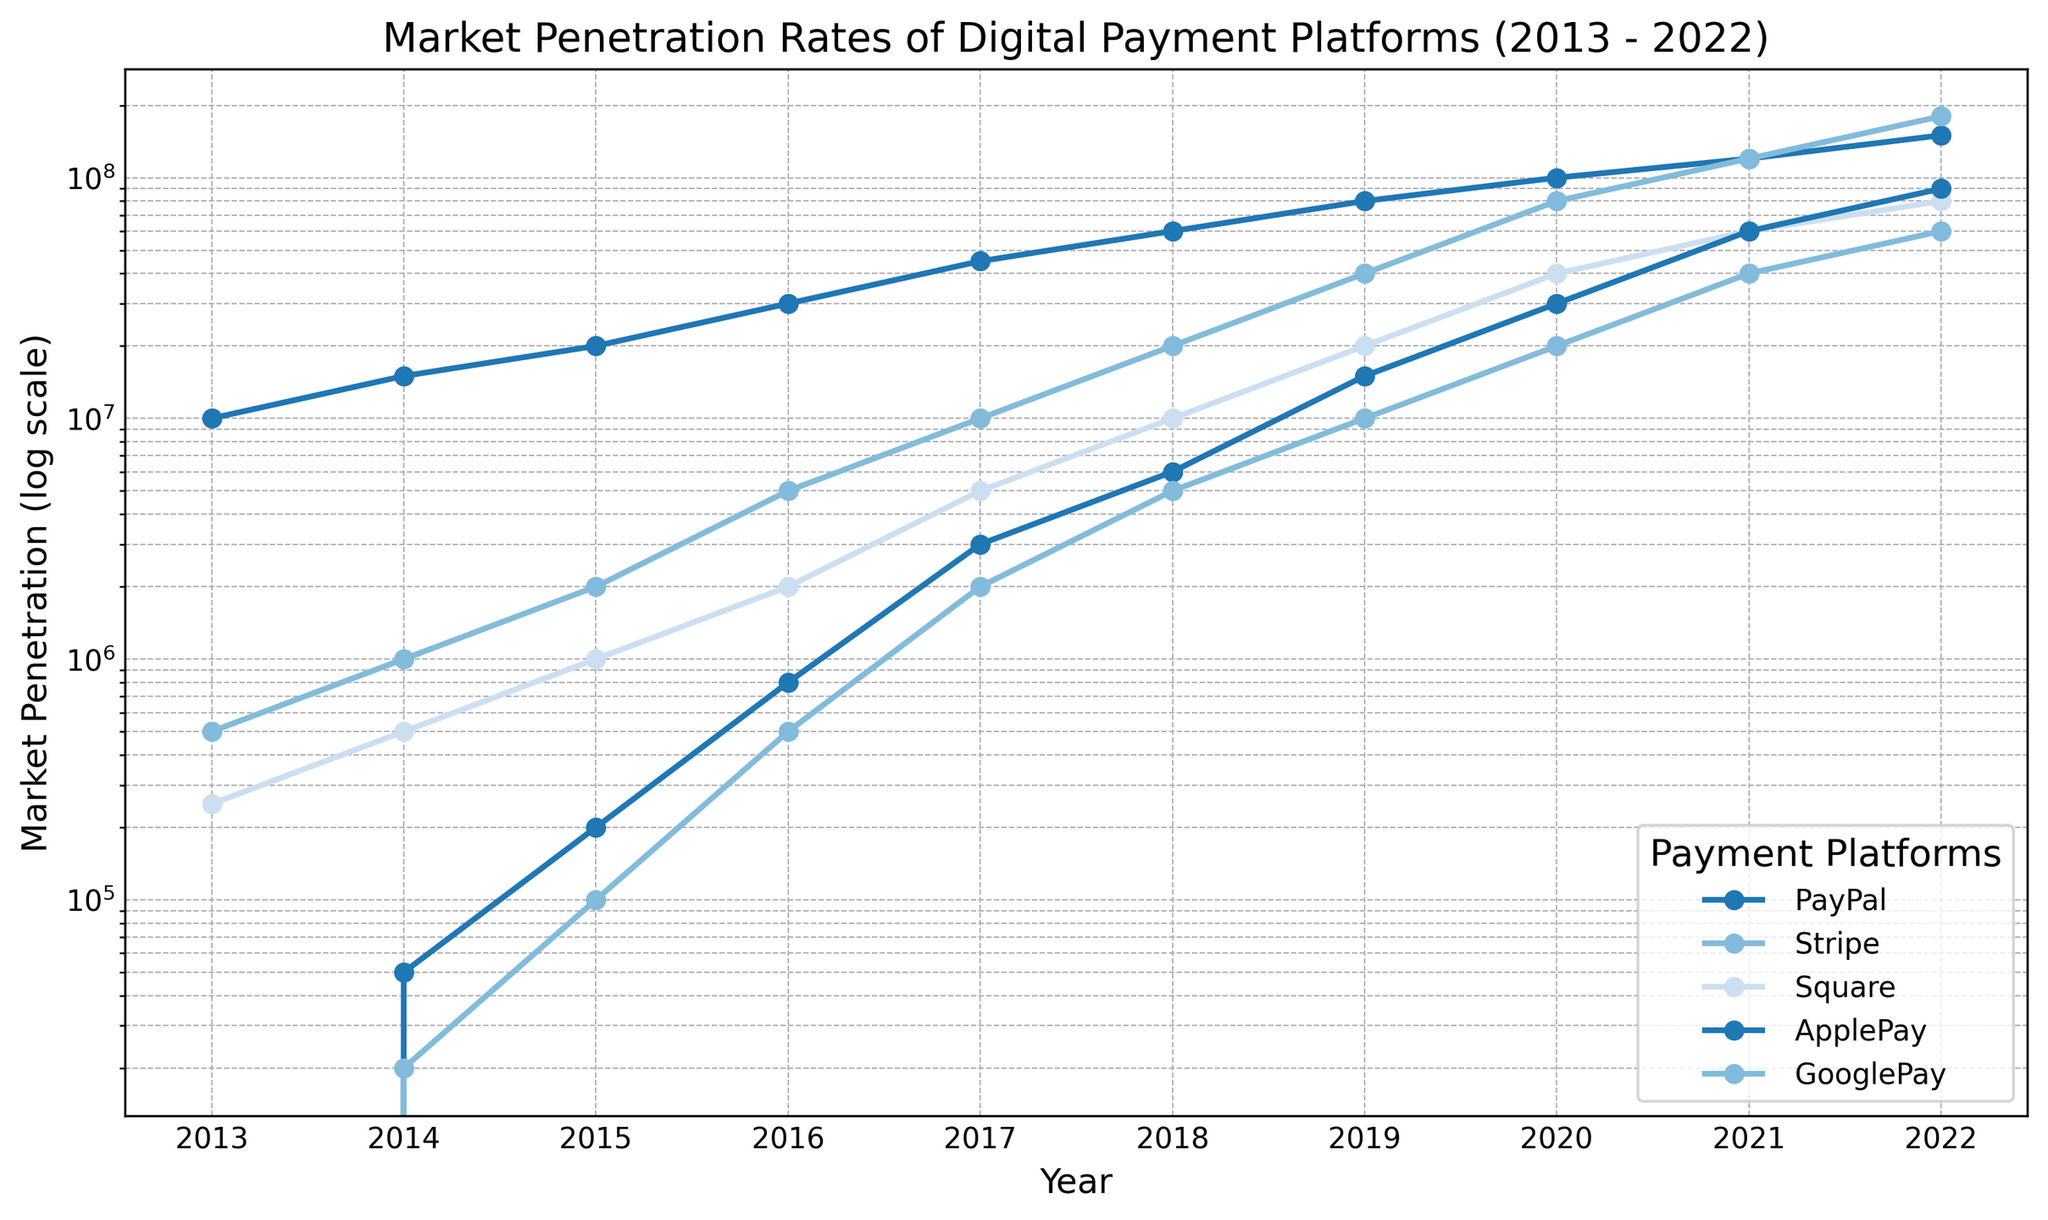What platform showed the largest growth in market penetration from 2013 to 2022? To determine the platform with the largest growth, calculate the difference between the market penetration in 2022 and 2013 for each platform. PayPal: 150,000,000 - 10,000,000 = 140,000,000; Stripe: 180,000,000 - 500,000 = 179,500,000; Square: 80,000,000 - 250,000 = 79,750,000; ApplePay: 90,000,000 - 0 = 90,000,000; GooglePay: 60,000,000 - 0 = 60,000,000. Stripe shows the largest growth of 179,500,000.
Answer: Stripe Which year did ApplePay surpass Square in market penetration? Observe the plotted lines for ApplePay and Square and identify the year where ApplePay's line crosses above Square's line. In 2021, ApplePay surpassed Square.
Answer: 2021 By how much did Google's market penetration increase between 2015 and 2020? Find Google's market penetration in 2015 and 2020. Then, subtract the former from the latter: 20,000,000 - 100,000 = 19,900,000.
Answer: 19,900,000 In which year did Stripe's market penetration equal or exceed PayPal's? Scan the logscale chart to locate the year where Stripe's line meets or exceeds PayPal's line. This occurs in 2021.
Answer: 2021 What is the total market penetration of all platforms combined in 2018? Sum the values of all platforms in 2018: PayPal (60,000,000) + Stripe (20,000,000) + Square (10,000,000) + ApplePay (6,000,000) + GooglePay (5,000,000) = 101,000,000.
Answer: 101,000,000 Which platform had consistent exponential growth over the decade according to the visual trend? Identify the platform that consistently shows an upward trend following an exponential growth pattern. Both PayPal and Stripe have exponential growth patterns, but PayPal is more consistent across the decade.
Answer: PayPal Comparing 2020 and 2022, which platform exhibited the highest increase in market penetration, and by how much? Calculate the increase for each platform: PayPal: 150,000,000 - 100,000,000 = 50,000,000; Stripe: 180,000,000 - 80,000,000 = 100,000,000; Square: 80,000,000 - 40,000,000 = 40,000,000; ApplePay: 90,000,000 - 30,000,000 = 60,000,000; GooglePay: 60,000,000 - 20,000,000 = 40,000,000. Stripe had the highest increase of 100,000,000.
Answer: Stripe, 100,000,000 